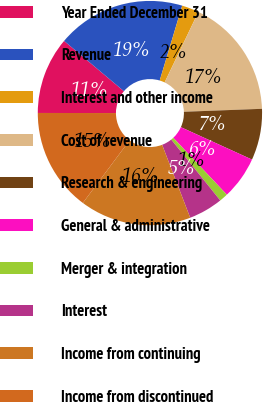Convert chart. <chart><loc_0><loc_0><loc_500><loc_500><pie_chart><fcel>Year Ended December 31<fcel>Revenue<fcel>Interest and other income<fcel>Cost of revenue<fcel>Research & engineering<fcel>General & administrative<fcel>Merger & integration<fcel>Interest<fcel>Income from continuing<fcel>Income from discontinued<nl><fcel>11.11%<fcel>18.52%<fcel>2.47%<fcel>17.28%<fcel>7.41%<fcel>6.17%<fcel>1.24%<fcel>4.94%<fcel>16.05%<fcel>14.81%<nl></chart> 